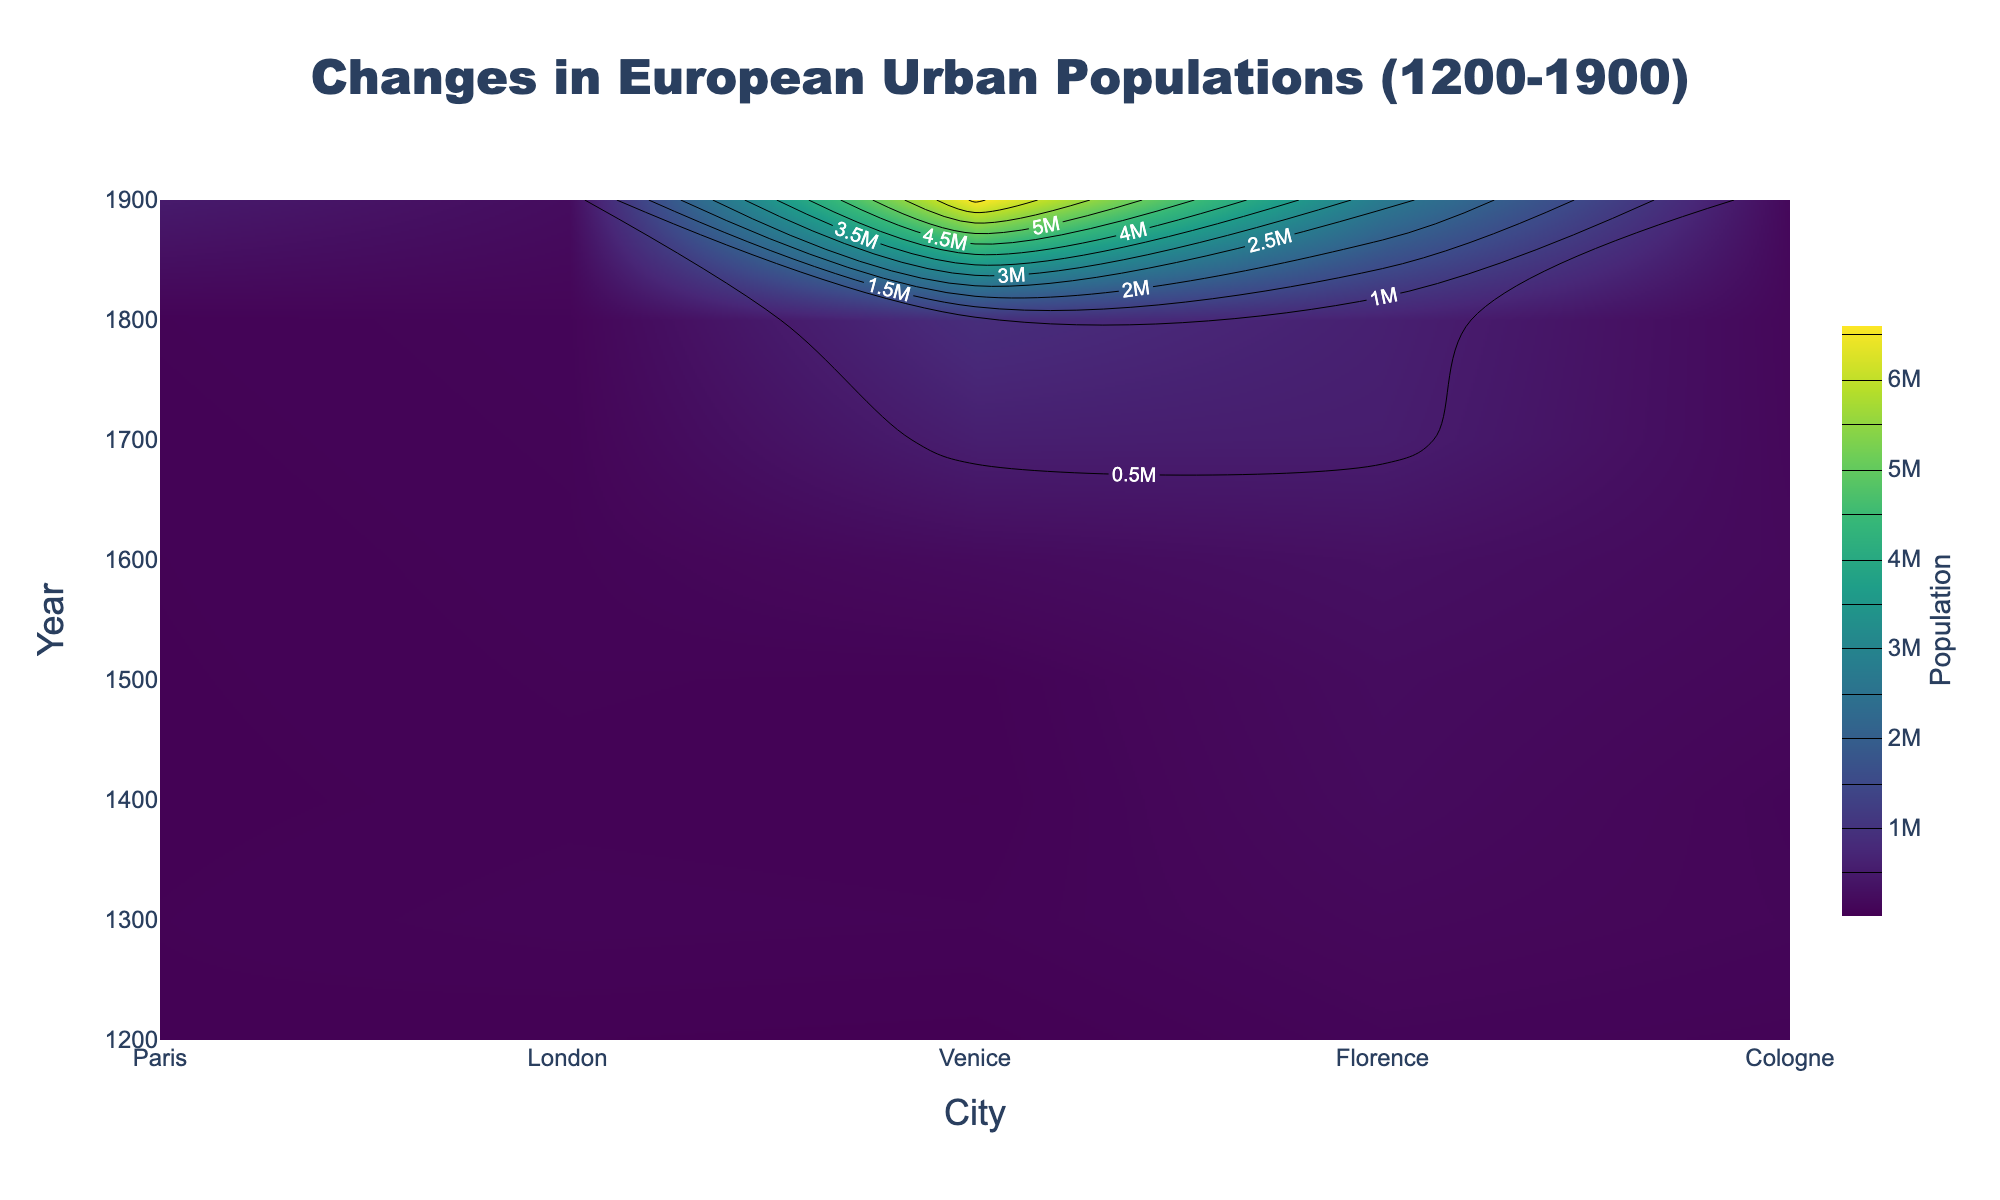What is the title of the figure? The title is usually displayed at the top of the plot. It provides a summary of what the figure is about.
Answer: Changes in European Urban Populations (1200-1900) What is the population of Paris in 1700? Locate Paris along the x-axis (cities) and trace it up to the y-axis value of 1700. The contour on the plot shows population data corresponding to this.
Answer: 550,000 How does the population of London in 1500 compare to that in 1700? First, locate London along the x-axis and find the values at 1500 and 1700 on the y-axis. Compare the population data shown on the contour plot for these two years.
Answer: The population increased from 60,000 in 1500 to 575,000 in 1700 Which city had the highest population in 1800? Trace along the y-axis value of 1800 and compare the heights of the contour lines among the cities. The highest value indicates the city with the highest population.
Answer: London By how much did the population of Florence grow between 1600 and 1900? Locate Florence on the x-axis and track the contour lines at 1600 and 1900 on the y-axis. Subtract the 1600 population from the 1900 population.
Answer: Growth of 150,000 (230,000 in 1900 - 80,000 in 1600) During which century did Paris experience the largest population growth? Look at the contour lines for Paris across the different centuries (1200-1900). Calculate the differences in population between the start and end of each century and identify the century with the largest increase.
Answer: 19th Century (from 600,000 to 2,700,000) Compare the population trends of Venice and Cologne from 1200 to 1900. Which city saw a steadier growth? Trace the contour lines for Venice and Cologne from 1200 to 1900 and observe their slopes. A steadier growth will have more evenly spaced contour lines over the period.
Answer: Cologne What was the average population of London during the 1400s? Locate London and the y-axis values corresponding to the 1400s. Identify the population values at those points and calculate the average.
Answer: 50,000 (since only one value, no calculation needed) Which two cities had approximately equal populations in 1600? Locate the contour lines for all cities at the y-axis value of 1600 and compare their population values.
Answer: Venice and Florence (both around 170,000) 